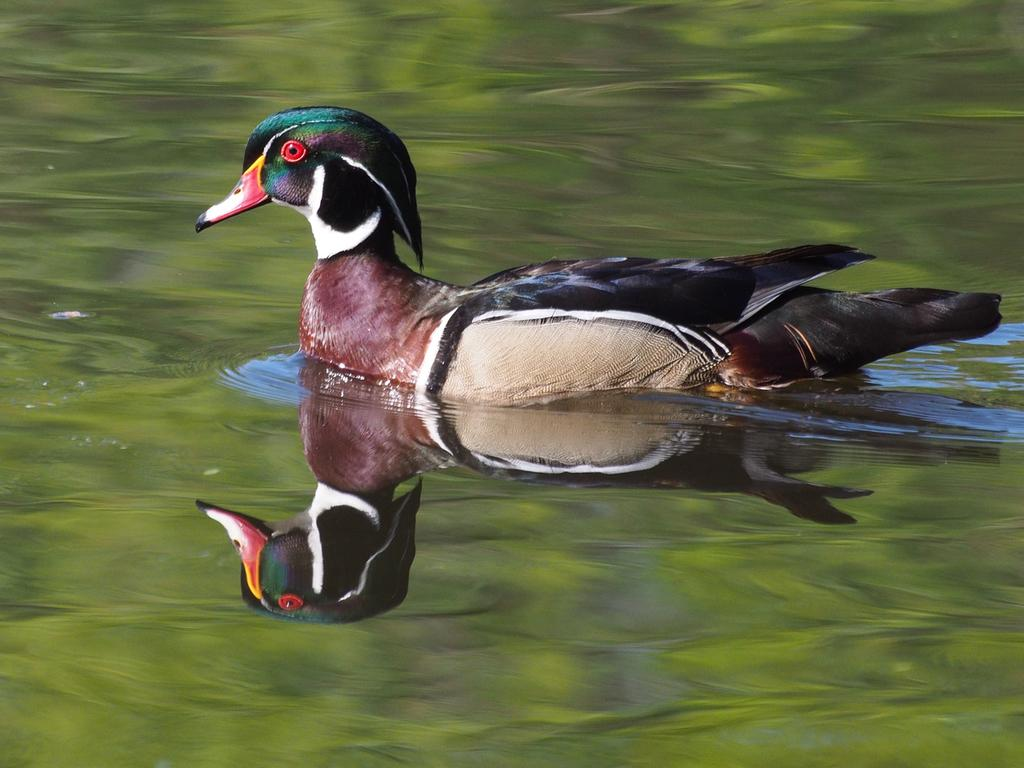What type of animal can be seen in the image? There is a bird in the image. What is the bird doing in the image? The bird is swimming in the water. What type of cap is the bird wearing in the image? There is no cap present on the bird in the image. Can you read any letters on the bird's body in the image? There are no letters visible on the bird's body in the image. 